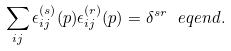<formula> <loc_0><loc_0><loc_500><loc_500>\sum _ { i j } \epsilon ^ { ( s ) } _ { i j } ( p ) \epsilon ^ { ( r ) } _ { i j } ( p ) = \delta ^ { s r } \ e q e n d { . }</formula> 